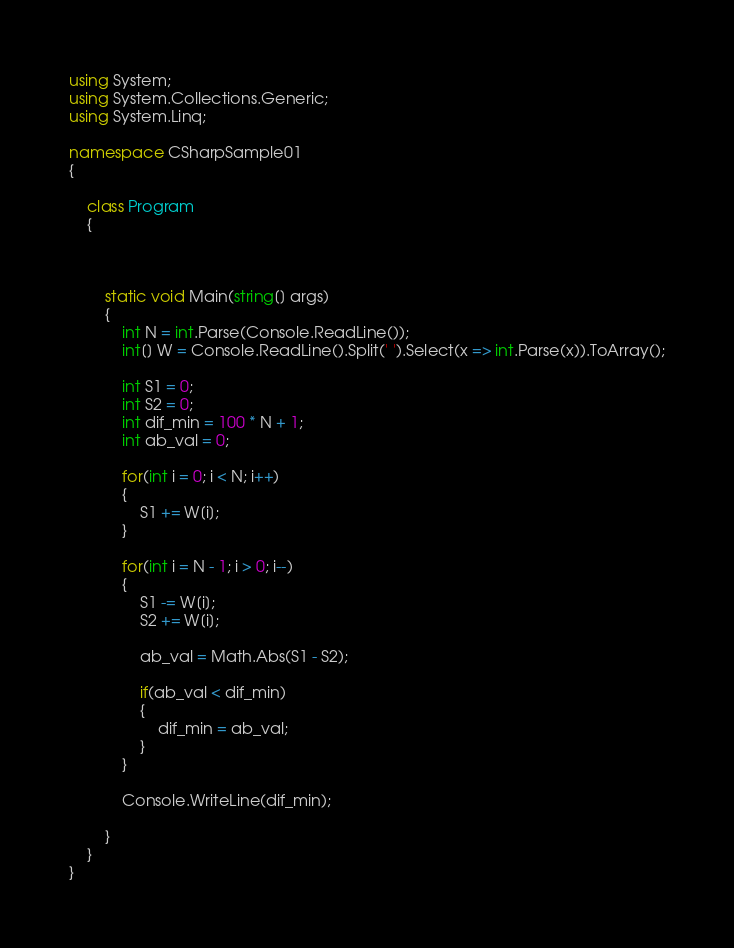<code> <loc_0><loc_0><loc_500><loc_500><_C#_>using System;
using System.Collections.Generic;
using System.Linq;

namespace CSharpSample01
{
    
    class Program
    {

        
        
        static void Main(string[] args)
        {
            int N = int.Parse(Console.ReadLine());
            int[] W = Console.ReadLine().Split(' ').Select(x => int.Parse(x)).ToArray();

            int S1 = 0;
            int S2 = 0;
            int dif_min = 100 * N + 1;
            int ab_val = 0;

            for(int i = 0; i < N; i++)
            {
                S1 += W[i];
            }

            for(int i = N - 1; i > 0; i--)
            {
                S1 -= W[i];
                S2 += W[i];

                ab_val = Math.Abs(S1 - S2);

                if(ab_val < dif_min)
                {
                    dif_min = ab_val;
                }
            }

            Console.WriteLine(dif_min);
        
        }
    }
}</code> 